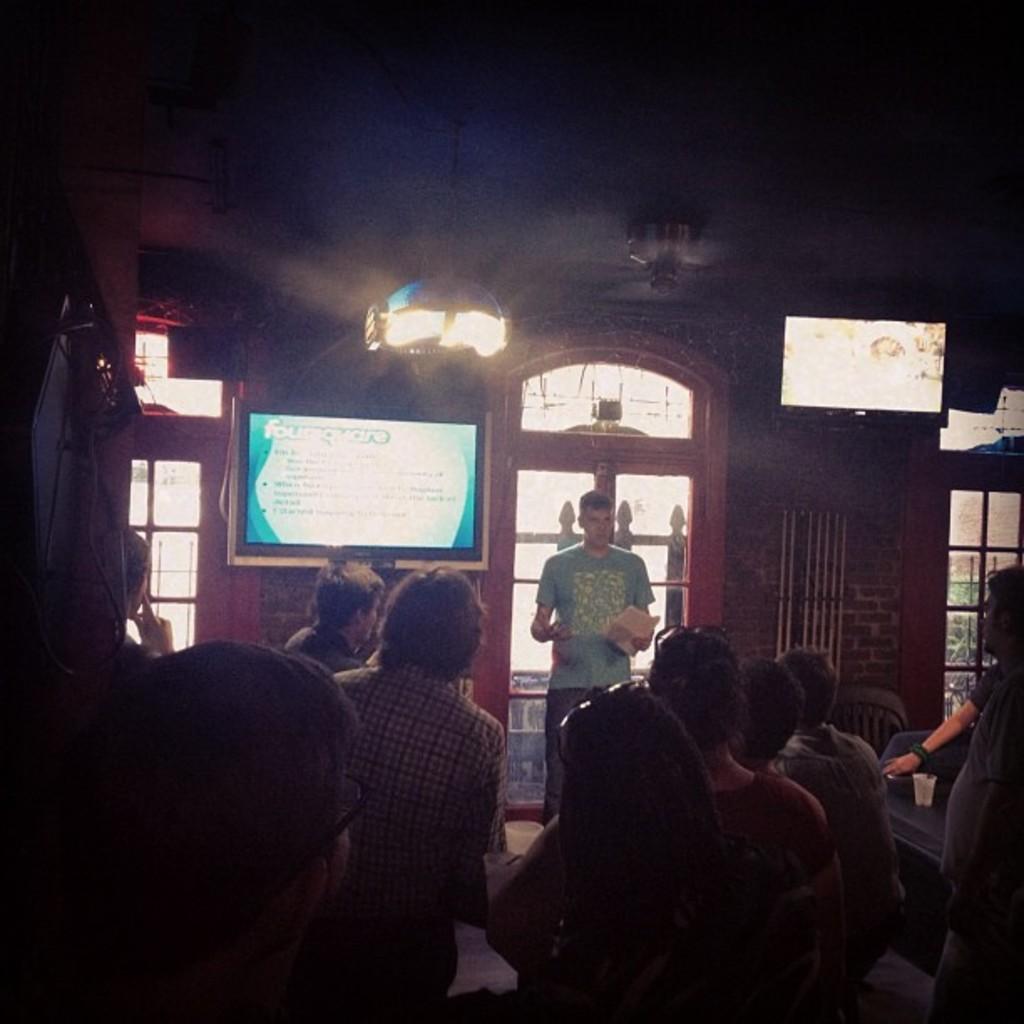In one or two sentences, can you explain what this image depicts? In the picture I can see people among them one man is standing and others are sitting on chairs. In the background I can see lights on the ceiling, two TV's, windows and some other objects. 